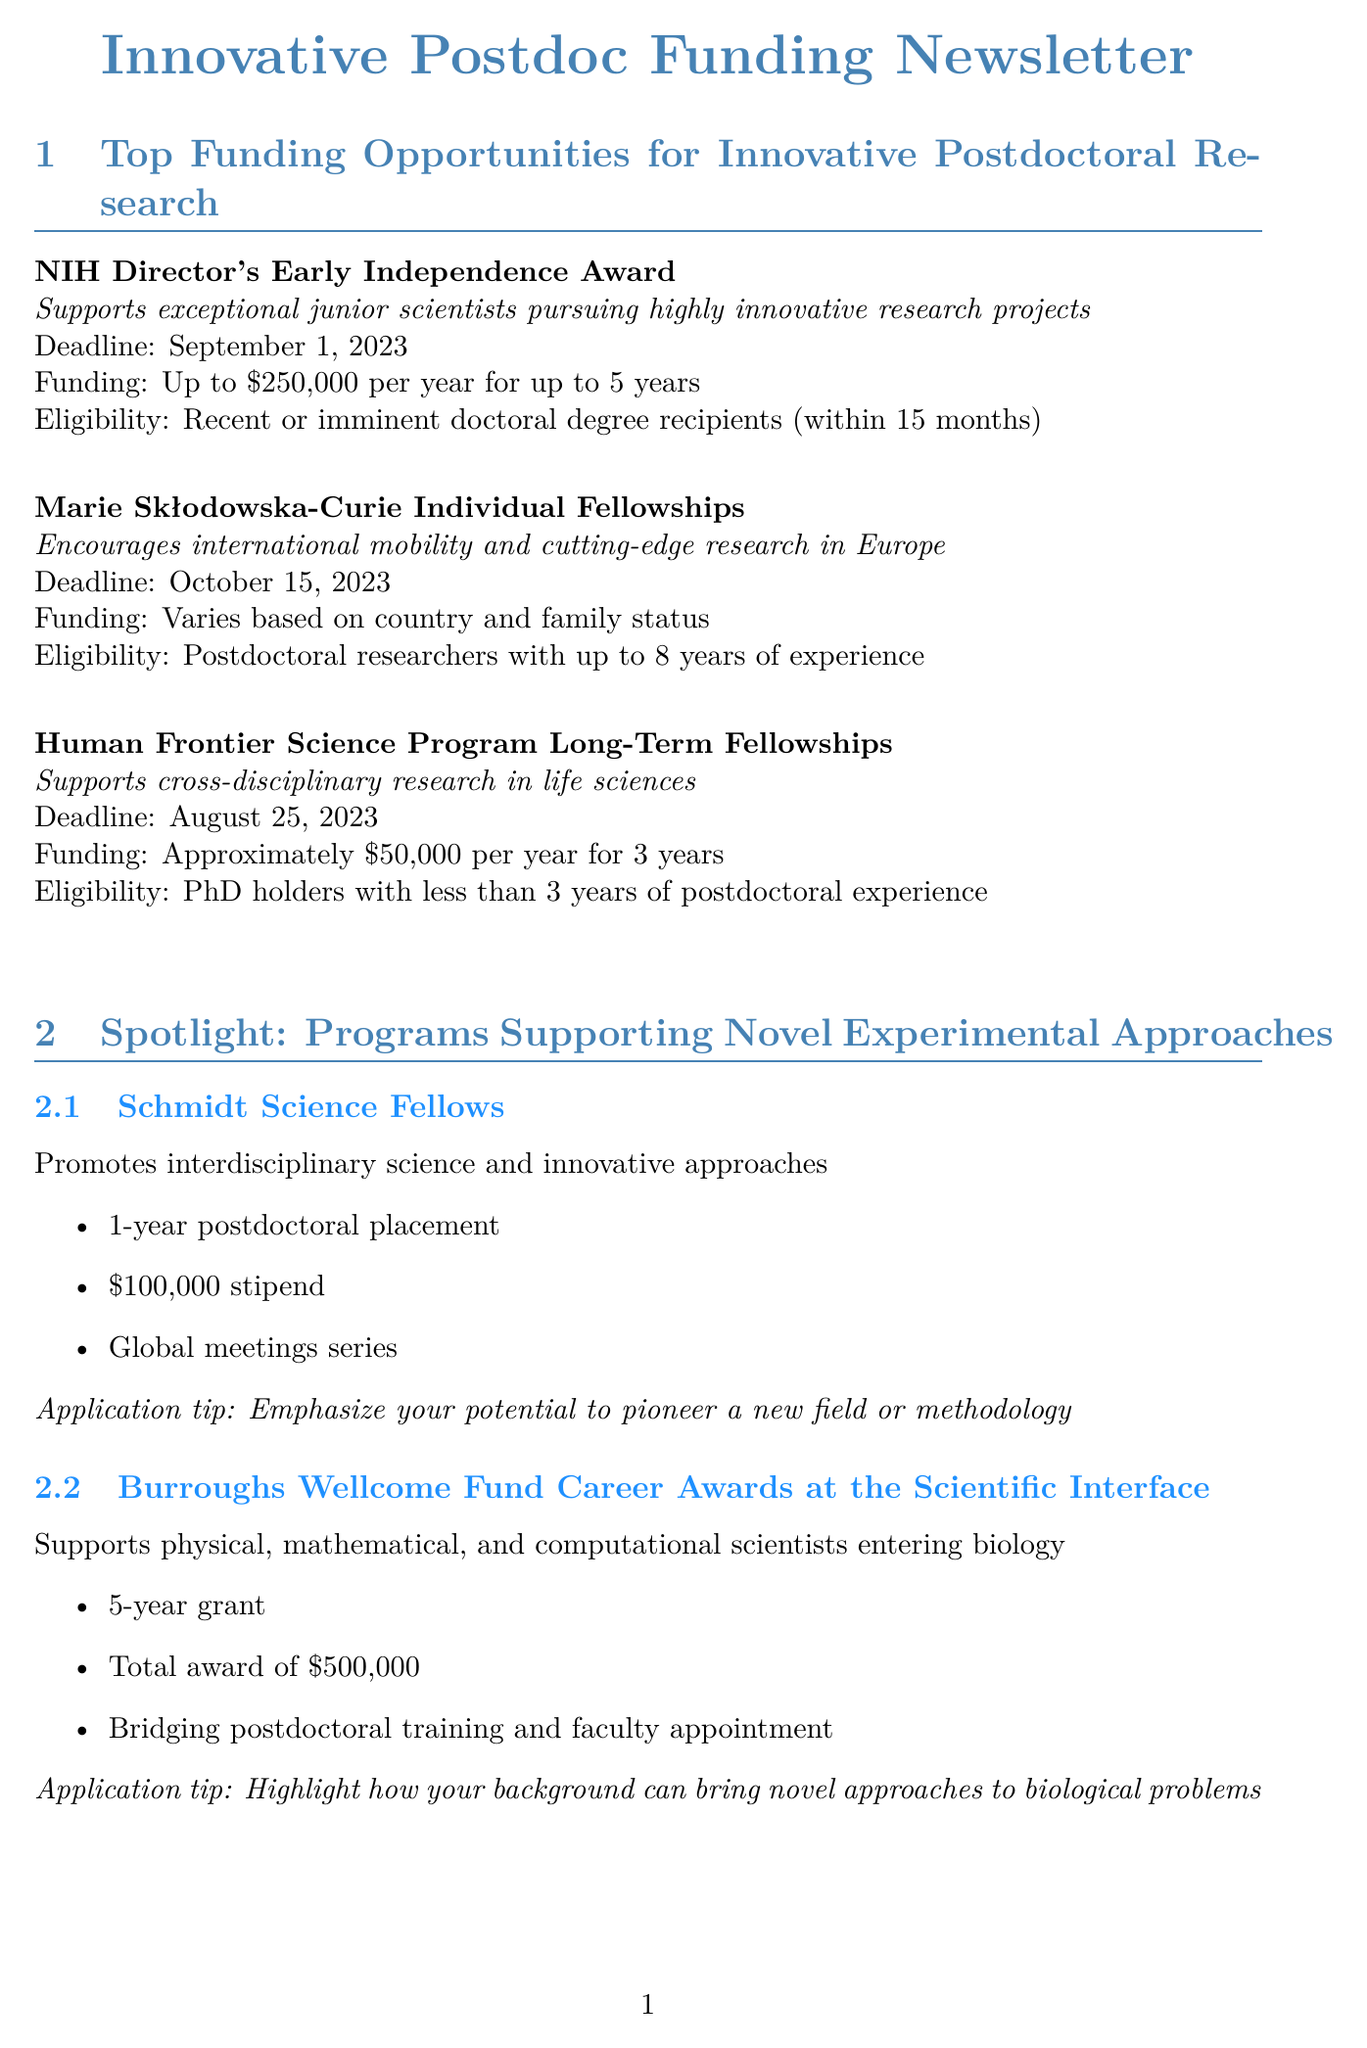what is the funding amount for the NIH Director's Early Independence Award? The funding amount is specified in the document as a maximum amount available for the program.
Answer: Up to $250,000 per year for up to 5 years when is the deadline for the Marie Skłodowska-Curie Individual Fellowships? The deadline for the fellowship is explicitly mentioned in the document.
Answer: October 15, 2023 what is the total award of the Burroughs Wellcome Fund Career Awards? The total award amount is provided in the description of the program.
Answer: $500,000 which program supports cross-disciplinary research in life sciences? The program name is cited in the section detailing funding opportunities.
Answer: Human Frontier Science Program Long-Term Fellowships what key innovation did Dr. Emily Chen develop? The innovation is highlighted in the success story section, detailing the researcher's achievement.
Answer: A novel microfluidic device for single-cell analysis how long is the postdoctoral placement for Schmidt Science Fellows? The duration of the placement is mentioned under the program specifics.
Answer: 1-year what should applicants emphasize in their applications to the Schmidt Science Fellows program? The document includes specific application tips for this program.
Answer: Potential to pioneer a new field or methodology which organization hosts the NIH Grant Writing Bootcamp for Postdocs? The hosting organization is specified in the workshop section of the newsletter.
Answer: NIH Office of Intramural Training & Education what is the main focus of the funding opportunities section in this newsletter? The primary theme of this section can be inferred from its title.
Answer: Innovative postdoctoral research 